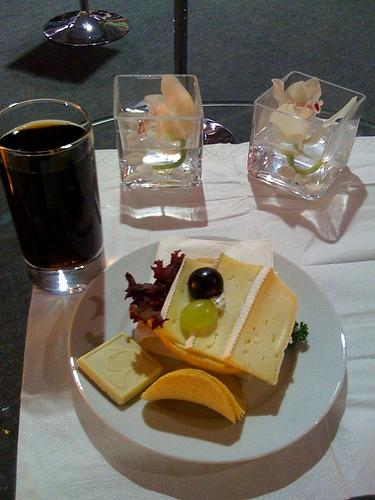What kind of chips are served on the plate?

Choices:
A) doritos
B) lays
C) pringles
D) stacys pringles 